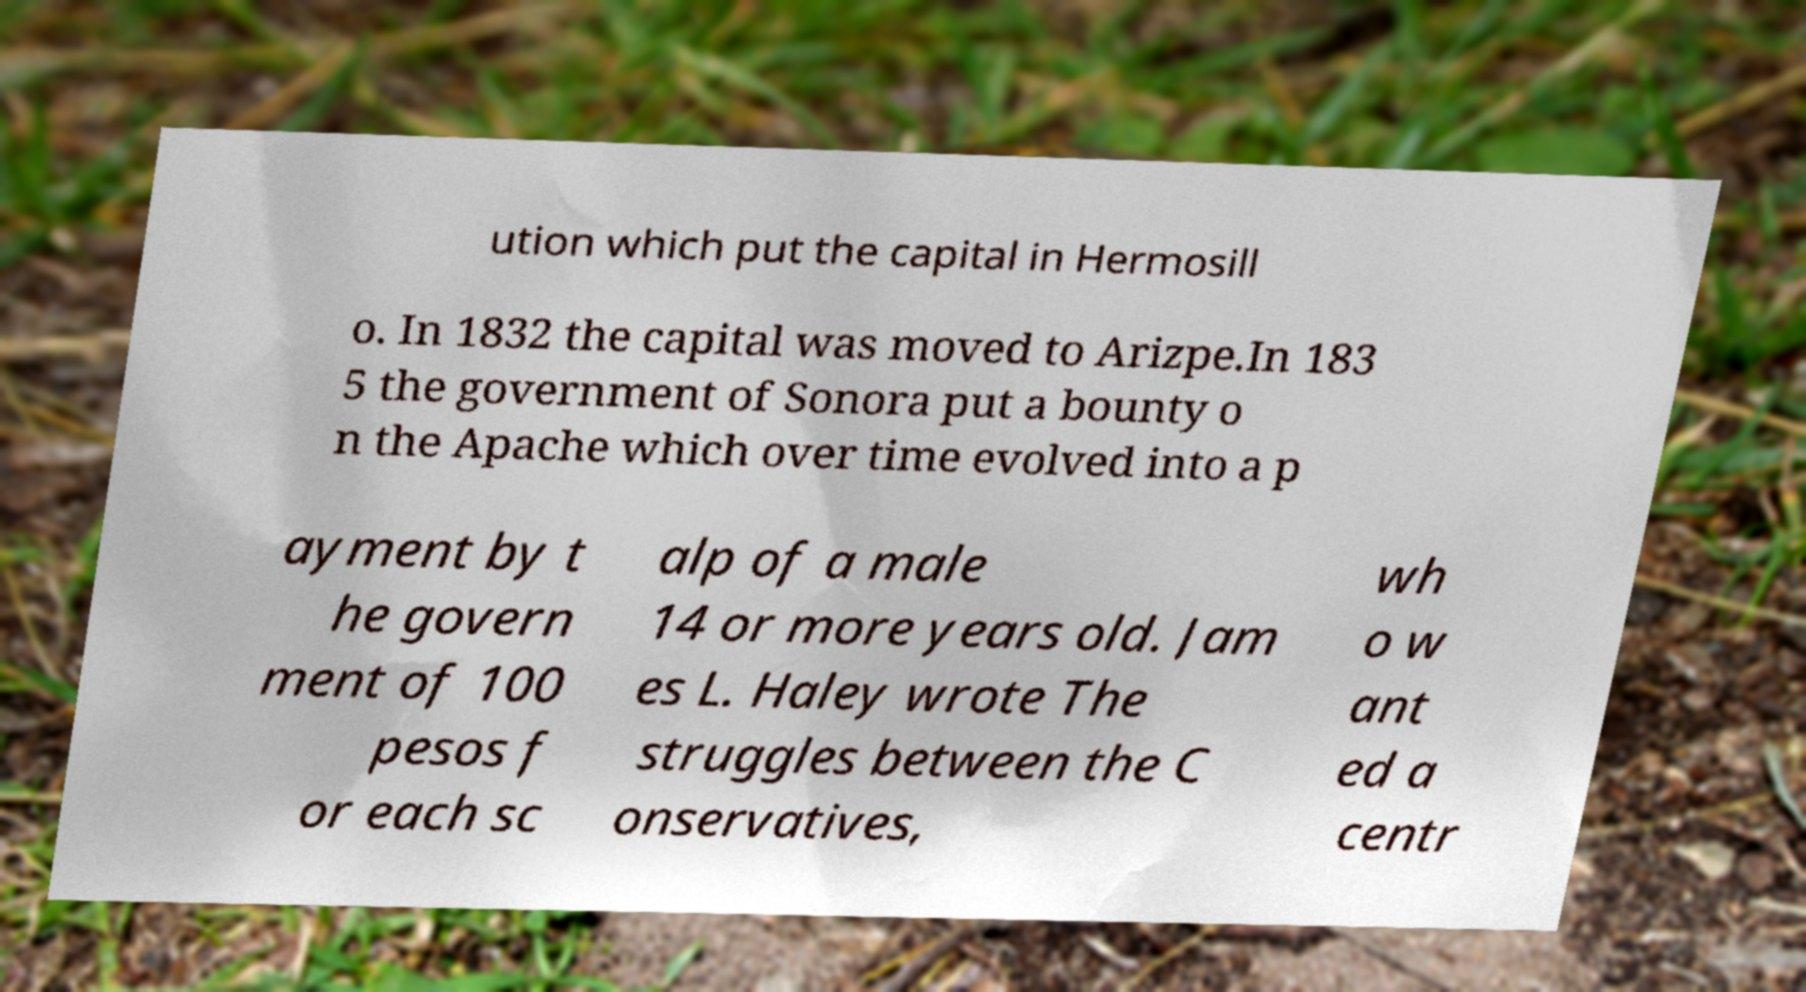Please read and relay the text visible in this image. What does it say? ution which put the capital in Hermosill o. In 1832 the capital was moved to Arizpe.In 183 5 the government of Sonora put a bounty o n the Apache which over time evolved into a p ayment by t he govern ment of 100 pesos f or each sc alp of a male 14 or more years old. Jam es L. Haley wrote The struggles between the C onservatives, wh o w ant ed a centr 